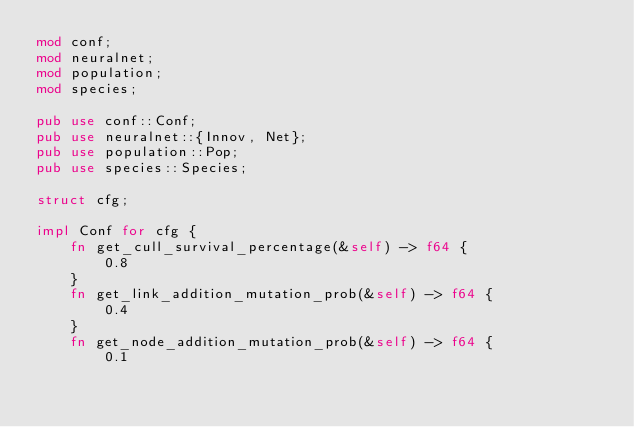<code> <loc_0><loc_0><loc_500><loc_500><_Rust_>mod conf;
mod neuralnet;
mod population;
mod species;

pub use conf::Conf;
pub use neuralnet::{Innov, Net};
pub use population::Pop;
pub use species::Species;

struct cfg;

impl Conf for cfg {
    fn get_cull_survival_percentage(&self) -> f64 {
        0.8
    }
    fn get_link_addition_mutation_prob(&self) -> f64 {
        0.4
    }
    fn get_node_addition_mutation_prob(&self) -> f64 {
        0.1</code> 